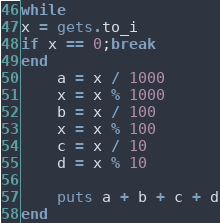Convert code to text. <code><loc_0><loc_0><loc_500><loc_500><_Ruby_>while
x = gets.to_i
if x == 0;break
end
    a = x / 1000
    x = x % 1000
    b = x / 100
    x = x % 100
    c = x / 10
    d = x % 10
    
    puts a + b + c + d
end

</code> 